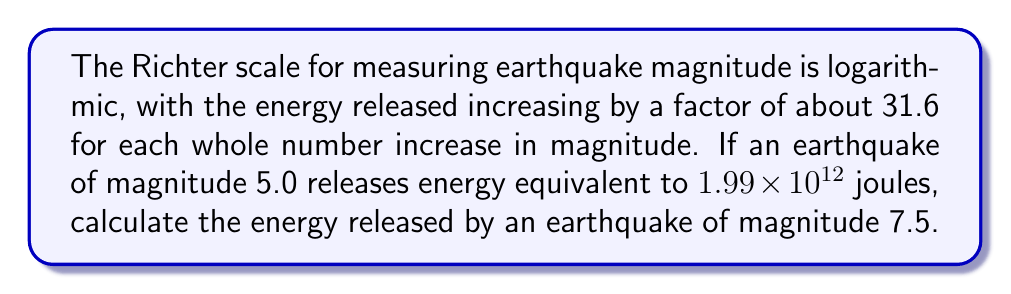Can you solve this math problem? Let's approach this step-by-step:

1) First, we need to understand the relationship between magnitude and energy release:
   For each whole number increase in magnitude, the energy increases by a factor of 31.6.

2) We're given that a magnitude 5.0 earthquake releases 1.99 × 10^12 joules.

3) We need to find the energy for a magnitude 7.5 earthquake. This is a difference of 2.5 magnitude units.

4) Let's calculate the energy increase factor:
   $$31.6^{2.5} = (31.6^{1/2})^5 \approx 5623.41$$

5) Now, we can calculate the energy released by the 7.5 magnitude earthquake:
   $$E_{7.5} = 1.99 \times 10^{12} \times 5623.41$$

6) Simplifying:
   $$E_{7.5} = 1.119 \times 10^{16} \text{ joules}$$

This result aligns with the logarithmic nature of the Richter scale, demonstrating the vast increase in energy release for higher magnitude earthquakes.
Answer: $1.119 \times 10^{16}$ joules 